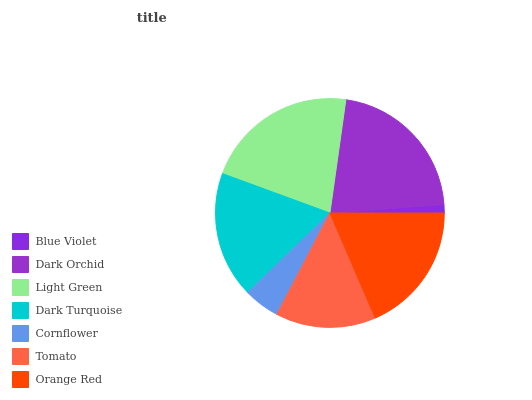Is Blue Violet the minimum?
Answer yes or no. Yes. Is Light Green the maximum?
Answer yes or no. Yes. Is Dark Orchid the minimum?
Answer yes or no. No. Is Dark Orchid the maximum?
Answer yes or no. No. Is Dark Orchid greater than Blue Violet?
Answer yes or no. Yes. Is Blue Violet less than Dark Orchid?
Answer yes or no. Yes. Is Blue Violet greater than Dark Orchid?
Answer yes or no. No. Is Dark Orchid less than Blue Violet?
Answer yes or no. No. Is Dark Turquoise the high median?
Answer yes or no. Yes. Is Dark Turquoise the low median?
Answer yes or no. Yes. Is Tomato the high median?
Answer yes or no. No. Is Orange Red the low median?
Answer yes or no. No. 